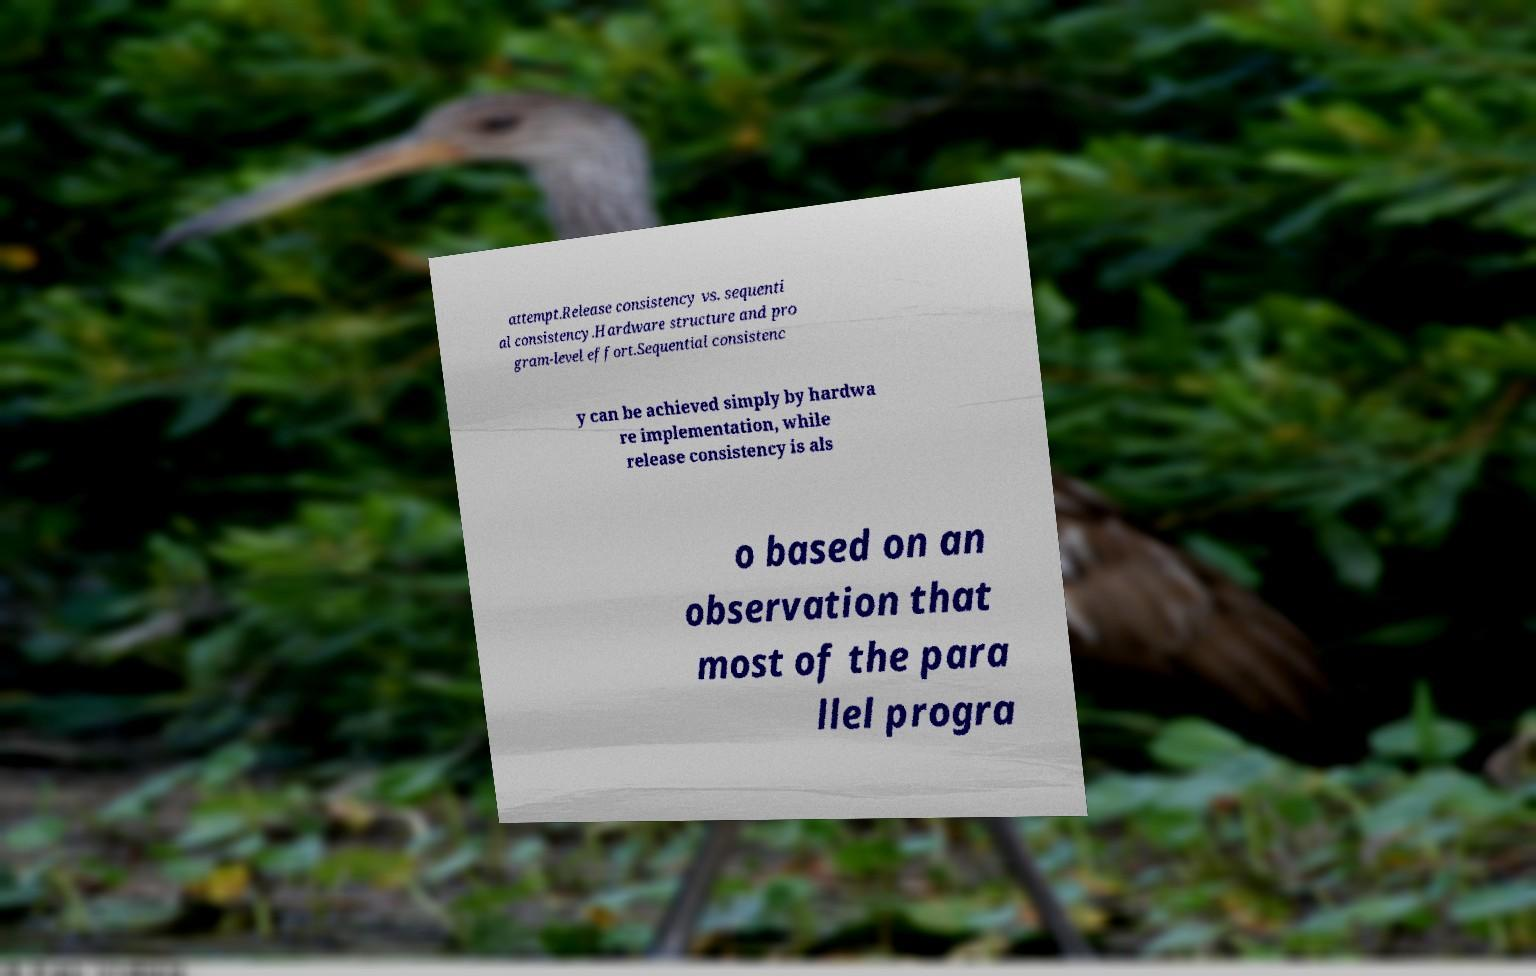Please identify and transcribe the text found in this image. attempt.Release consistency vs. sequenti al consistency.Hardware structure and pro gram-level effort.Sequential consistenc y can be achieved simply by hardwa re implementation, while release consistency is als o based on an observation that most of the para llel progra 